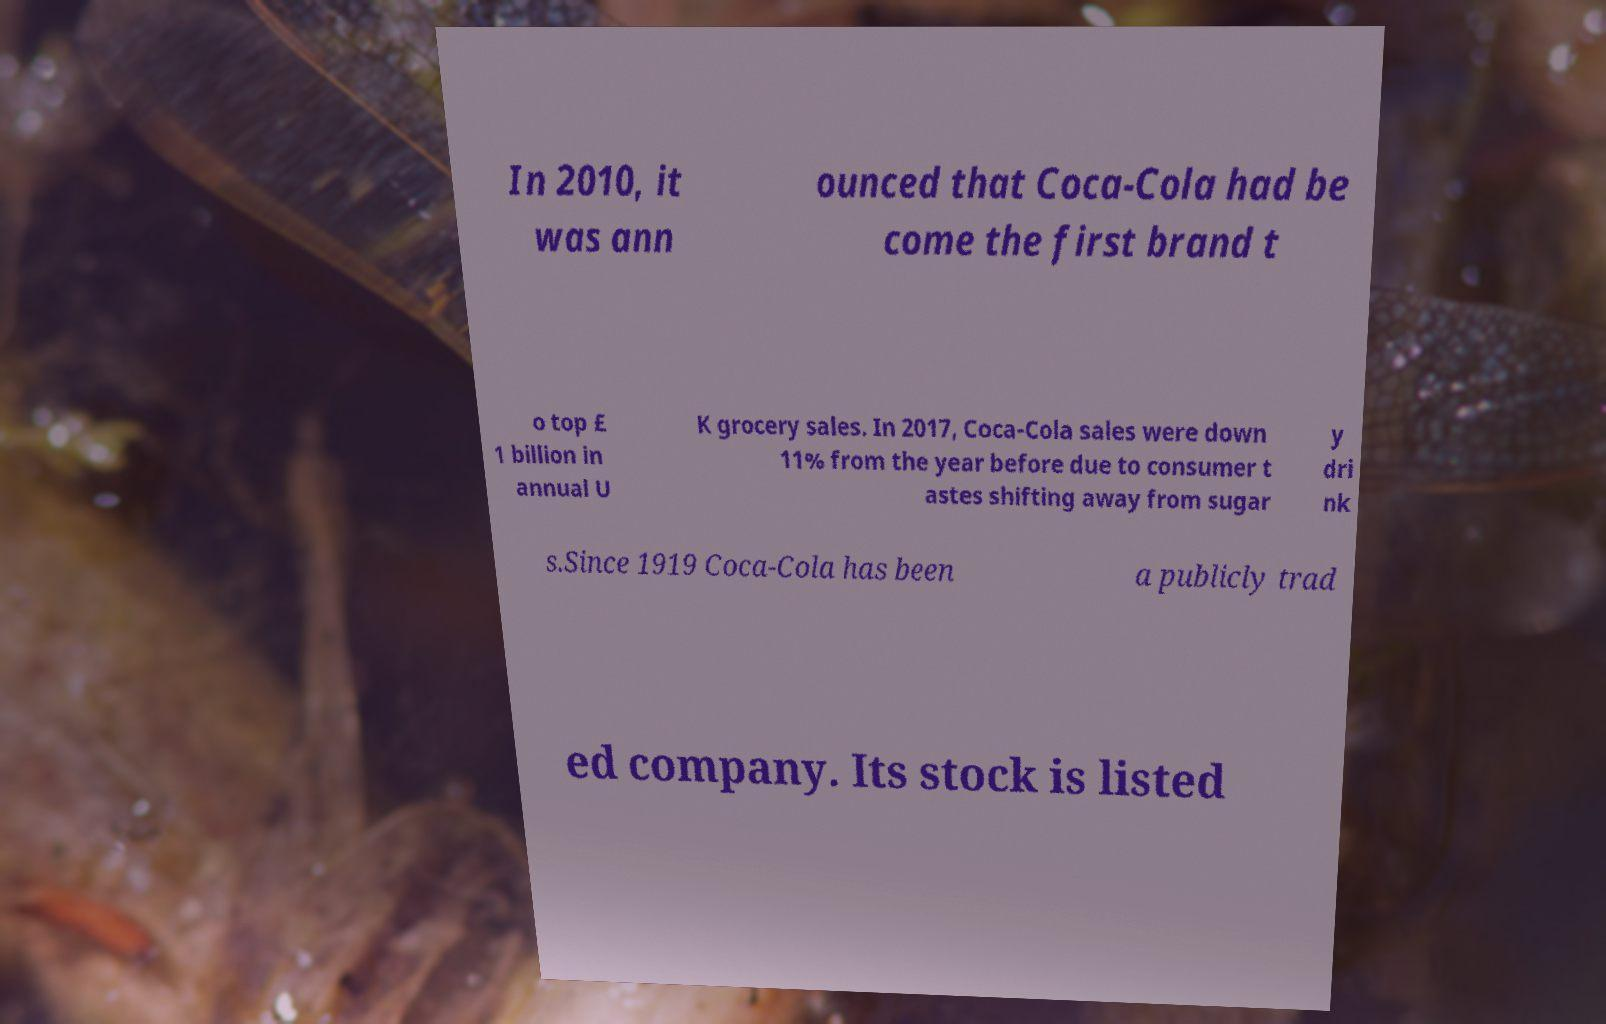Can you read and provide the text displayed in the image?This photo seems to have some interesting text. Can you extract and type it out for me? In 2010, it was ann ounced that Coca-Cola had be come the first brand t o top £ 1 billion in annual U K grocery sales. In 2017, Coca-Cola sales were down 11% from the year before due to consumer t astes shifting away from sugar y dri nk s.Since 1919 Coca-Cola has been a publicly trad ed company. Its stock is listed 